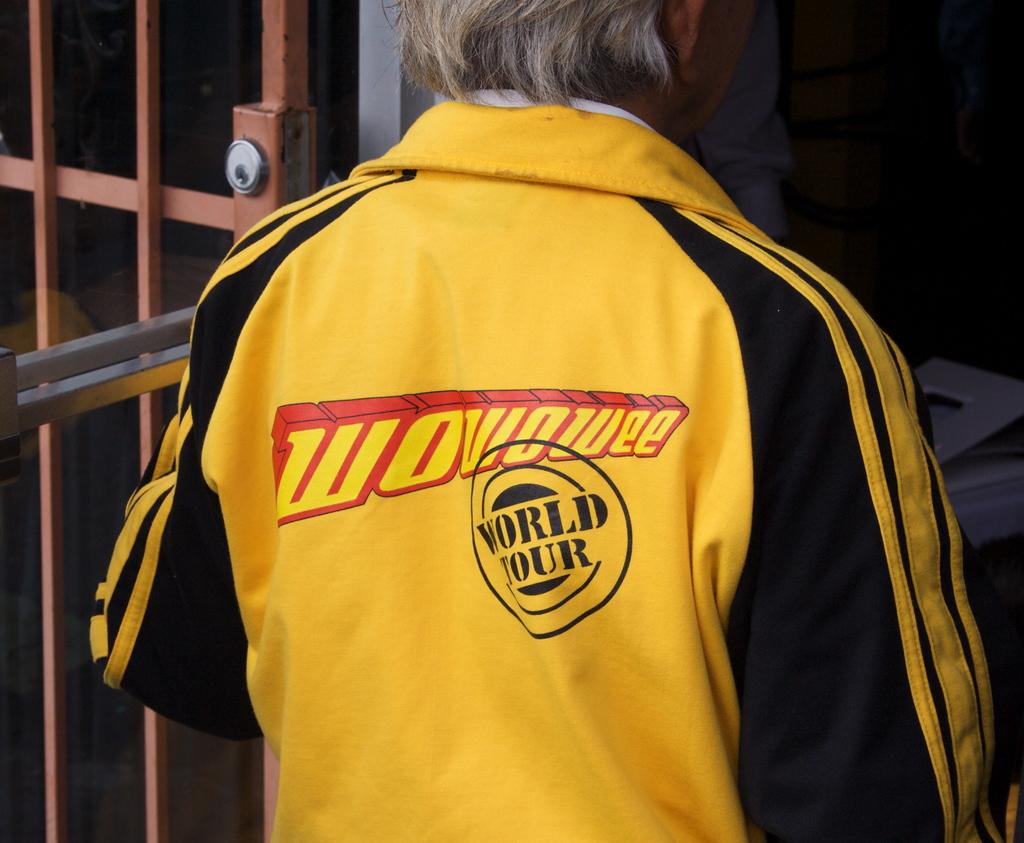Name the brand in red?
Your response must be concise. Wowowee. What worlds does it say in the black circle?
Your response must be concise. World tour. 